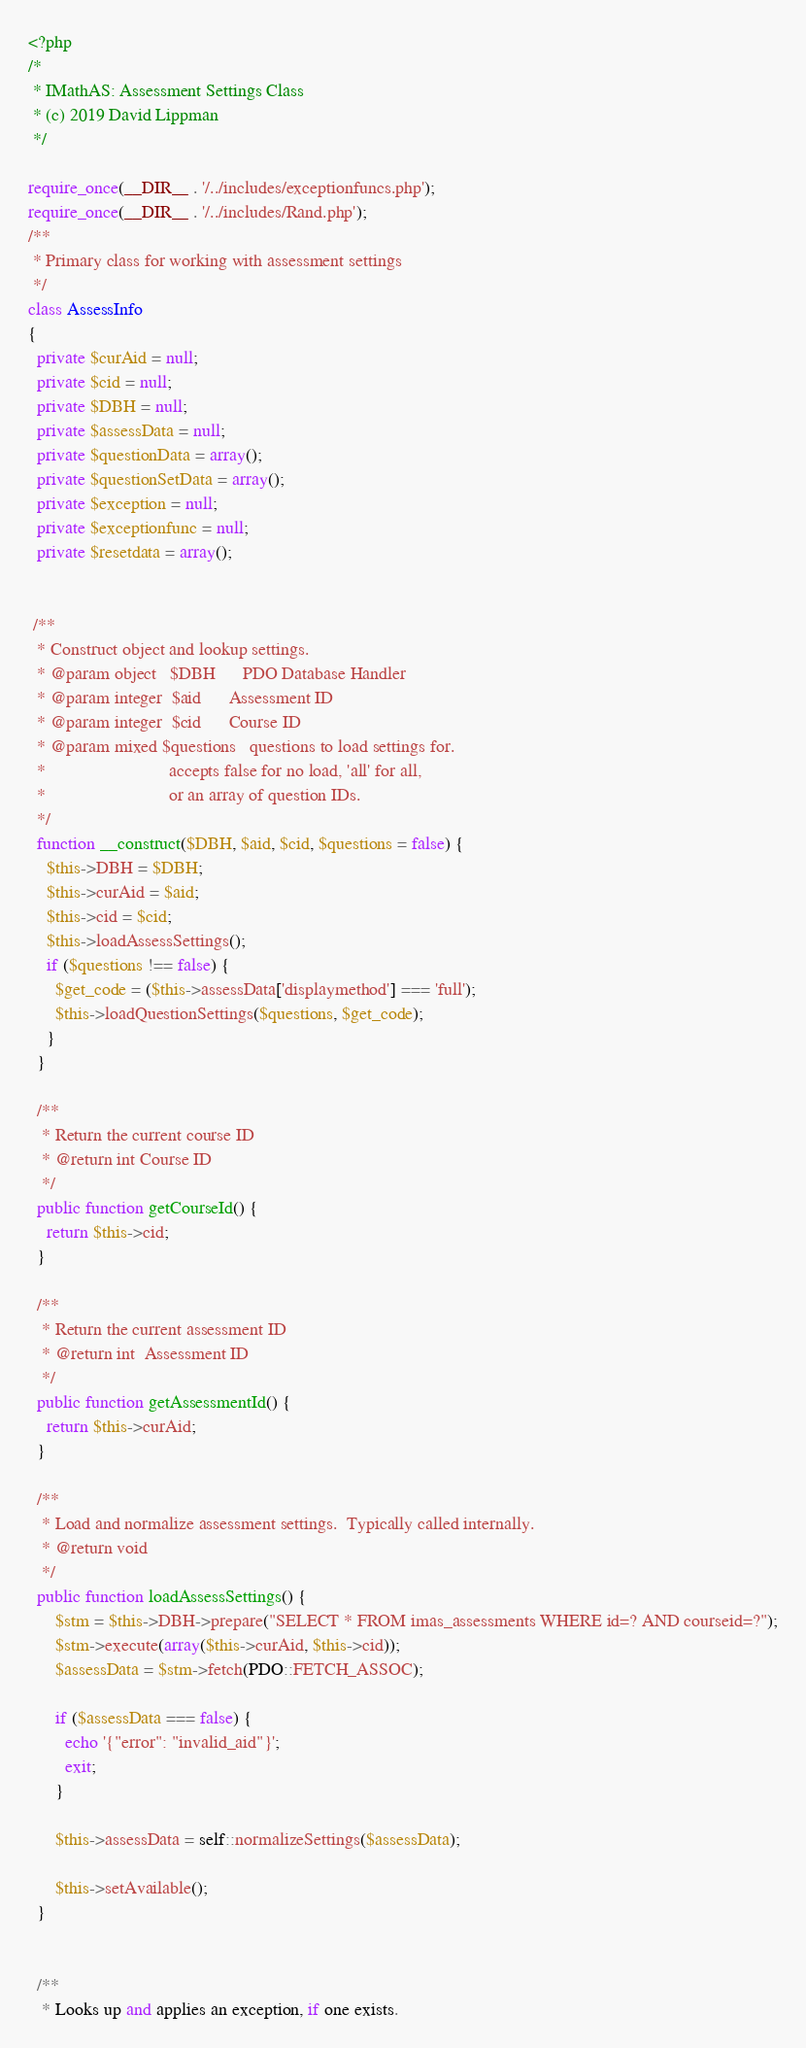Convert code to text. <code><loc_0><loc_0><loc_500><loc_500><_PHP_><?php
/*
 * IMathAS: Assessment Settings Class
 * (c) 2019 David Lippman
 */

require_once(__DIR__ . '/../includes/exceptionfuncs.php');
require_once(__DIR__ . '/../includes/Rand.php');
/**
 * Primary class for working with assessment settings
 */
class AssessInfo
{
  private $curAid = null;
  private $cid = null;
  private $DBH = null;
  private $assessData = null;
  private $questionData = array();
  private $questionSetData = array();
  private $exception = null;
  private $exceptionfunc = null;
  private $resetdata = array();


 /**
  * Construct object and lookup settings.
  * @param object   $DBH      PDO Database Handler
  * @param integer  $aid      Assessment ID
  * @param integer  $cid      Course ID
  * @param mixed $questions   questions to load settings for.
  *                           accepts false for no load, 'all' for all,
  *                           or an array of question IDs.
  */
  function __construct($DBH, $aid, $cid, $questions = false) {
    $this->DBH = $DBH;
    $this->curAid = $aid;
    $this->cid = $cid;
    $this->loadAssessSettings();
    if ($questions !== false) {
      $get_code = ($this->assessData['displaymethod'] === 'full');
      $this->loadQuestionSettings($questions, $get_code);
    }
  }

  /**
   * Return the current course ID
   * @return int Course ID
   */
  public function getCourseId() {
    return $this->cid;
  }

  /**
   * Return the current assessment ID
   * @return int  Assessment ID
   */
  public function getAssessmentId() {
    return $this->curAid;
  }

  /**
   * Load and normalize assessment settings.  Typically called internally.
   * @return void
   */
  public function loadAssessSettings() {
      $stm = $this->DBH->prepare("SELECT * FROM imas_assessments WHERE id=? AND courseid=?");
      $stm->execute(array($this->curAid, $this->cid));
      $assessData = $stm->fetch(PDO::FETCH_ASSOC);

      if ($assessData === false) {
        echo '{"error": "invalid_aid"}';
        exit;
      }

      $this->assessData = self::normalizeSettings($assessData);

      $this->setAvailable();
  }


  /**
   * Looks up and applies an exception, if one exists.</code> 